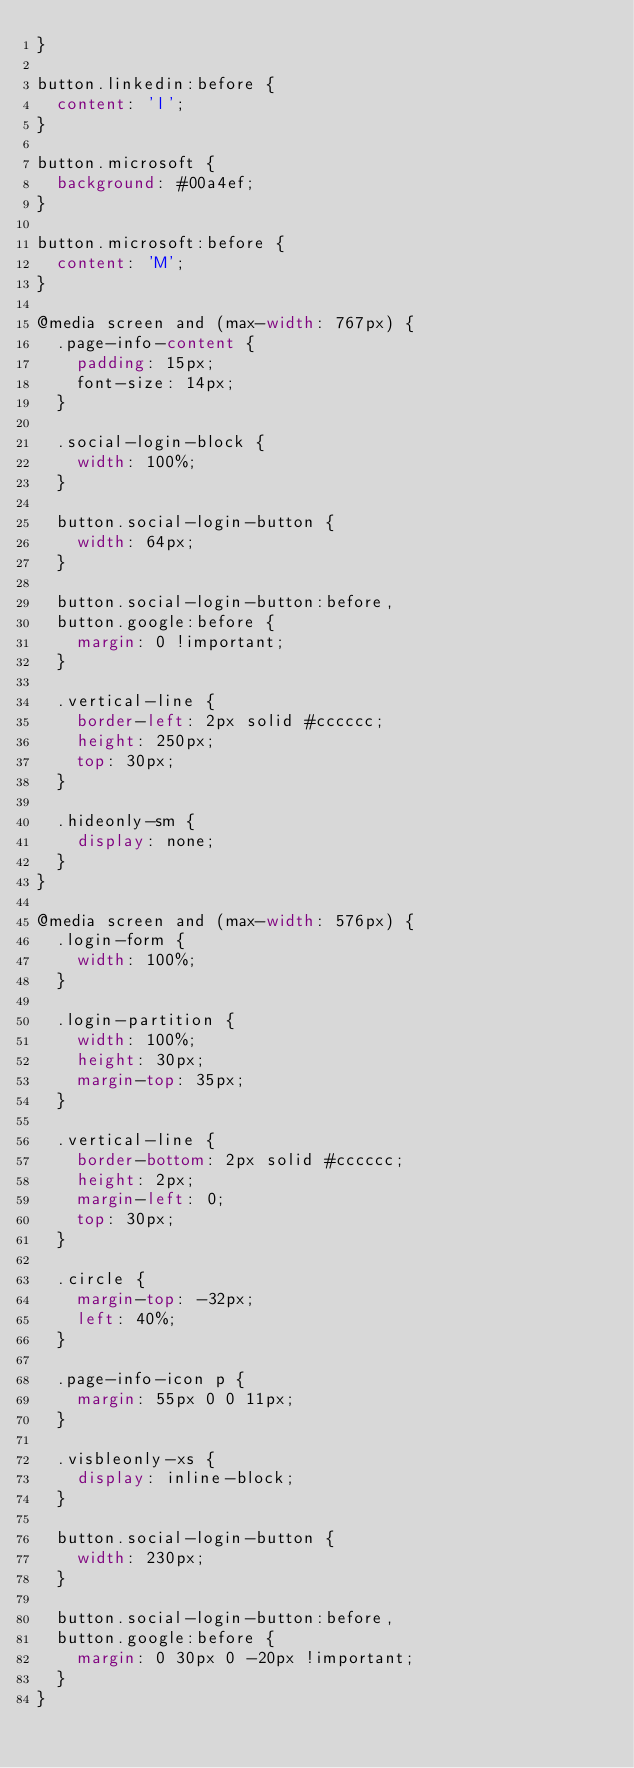Convert code to text. <code><loc_0><loc_0><loc_500><loc_500><_CSS_>}

button.linkedin:before {
  content: 'l';
}

button.microsoft {
  background: #00a4ef;
}

button.microsoft:before {
  content: 'M';
}

@media screen and (max-width: 767px) {
  .page-info-content {
    padding: 15px;
    font-size: 14px;
  }

  .social-login-block {
    width: 100%;
  }

  button.social-login-button {
    width: 64px;
  }

  button.social-login-button:before,
  button.google:before {
    margin: 0 !important;
  }

  .vertical-line {
    border-left: 2px solid #cccccc;
    height: 250px;
    top: 30px;
  }

  .hideonly-sm {
    display: none;
  }
}

@media screen and (max-width: 576px) {
  .login-form {
    width: 100%;
  }

  .login-partition {
    width: 100%;
    height: 30px;
    margin-top: 35px;
  }

  .vertical-line {
    border-bottom: 2px solid #cccccc;
    height: 2px;
    margin-left: 0;
    top: 30px;
  }

  .circle {
    margin-top: -32px;
    left: 40%;
  }

  .page-info-icon p {
    margin: 55px 0 0 11px;
  }

  .visbleonly-xs {
    display: inline-block;
  }

  button.social-login-button {
    width: 230px;
  }

  button.social-login-button:before,
  button.google:before {
    margin: 0 30px 0 -20px !important;
  }
}</code> 